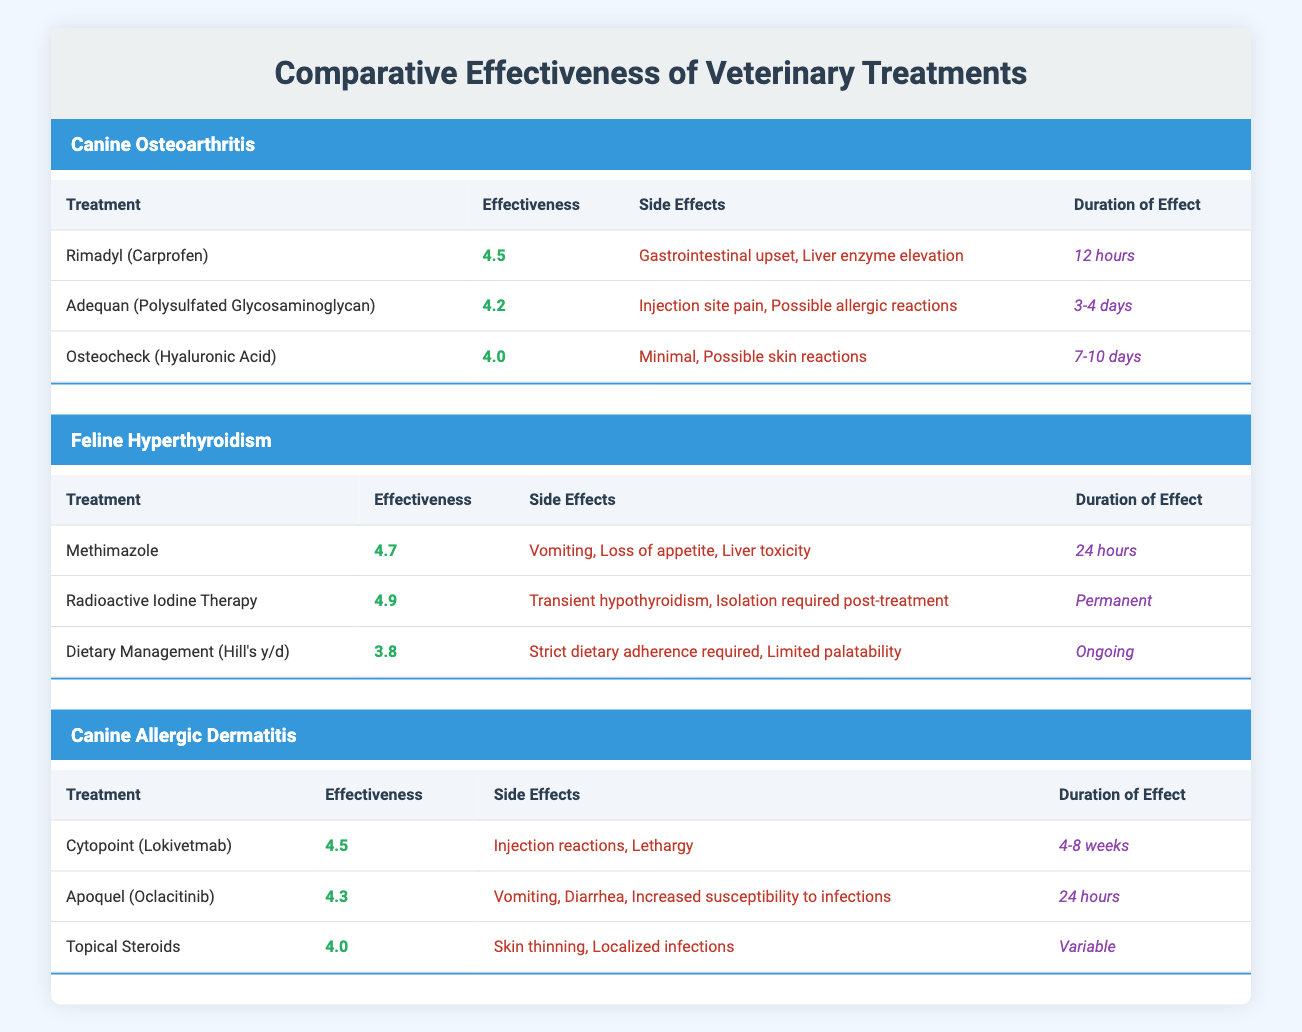What is the effectiveness rating of Rimadyl (Carprofen)? The effectiveness rating for Rimadyl (Carprofen) is listed directly in the 'Effectiveness' column under the condition 'Canine Osteoarthritis'. According to the table, it is 4.5.
Answer: 4.5 Which treatment for Feline Hyperthyroidism has the longest duration of effect? In the 'Feline Hyperthyroidism' section of the table, 'Radioactive Iodine Therapy' has a duration of effect labeled as 'Permanent', which is longer than the other treatments listed.
Answer: Radioactive Iodine Therapy Is there any treatment listed for Canine Allergic Dermatitis that has an effectiveness rating of 4.0 or higher? To answer this, we compare the effectiveness ratings for all treatments under 'Canine Allergic Dermatitis'. The treatments listed are 4.5 for Cytopoint, 4.3 for Apoquel, and 4.0 for Topical Steroids. Since all are 4.0 or higher, the answer is yes.
Answer: Yes What is the average effectiveness rating of the treatments for Canine Osteoarthritis? For the treatments listed under 'Canine Osteoarthritis', the effectiveness ratings are 4.5 (Rimadyl), 4.2 (Adequan), and 4.0 (Osteocheck). To find the average, we add these ratings: 4.5 + 4.2 + 4.0 = 12.7. There are three treatments, so we calculate the average: 12.7 / 3 = 4.23.
Answer: 4.23 Does Methimazole have any side effects related to appetite? Referring to the 'Side Effects' column for Methimazole in the 'Feline Hyperthyroidism' section, it states 'Loss of appetite' as one of the side effects. Therefore, the answer is yes, it does.
Answer: Yes Which treatment option for Canine Allergic Dermatitis has the shortest duration of effect? In the 'Canine Allergic Dermatitis' section, the options are Cytopoint (4-8 weeks), Apoquel (24 hours), and Topical Steroids (Variable). Comparing these, Apoquel has the shortest duration of effect at 24 hours.
Answer: Apoquel Are there any treatments in the table that require strict adherence to dietary management? The treatment listed under 'Feline Hyperthyroidism' as 'Dietary Management (Hill's y/d)' explicitly states that 'Strict dietary adherence required' as a side effect. Therefore, yes, there is such a treatment.
Answer: Yes What is the difference in effectiveness rating between the most effective and least effective treatments for Feline Hyperthyroidism? The highest effectiveness rating among treatments for Feline Hyperthyroidism is 4.9 for 'Radioactive Iodine Therapy', and the lowest is 3.8 for 'Dietary Management (Hill's y/d)'. The difference is 4.9 - 3.8 = 1.1.
Answer: 1.1 